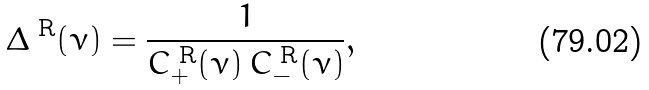Convert formula to latex. <formula><loc_0><loc_0><loc_500><loc_500>\Delta ^ { \text { R} } ( \nu ) = \frac { 1 } { C _ { + } ^ { \text { R} } ( \nu ) \, C _ { - } ^ { \text { R} } ( \nu ) } ,</formula> 